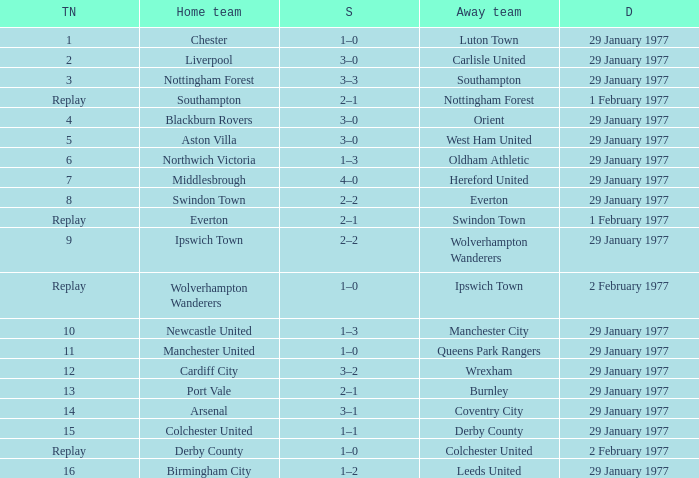Which away team has a tie number of 3? Southampton. 